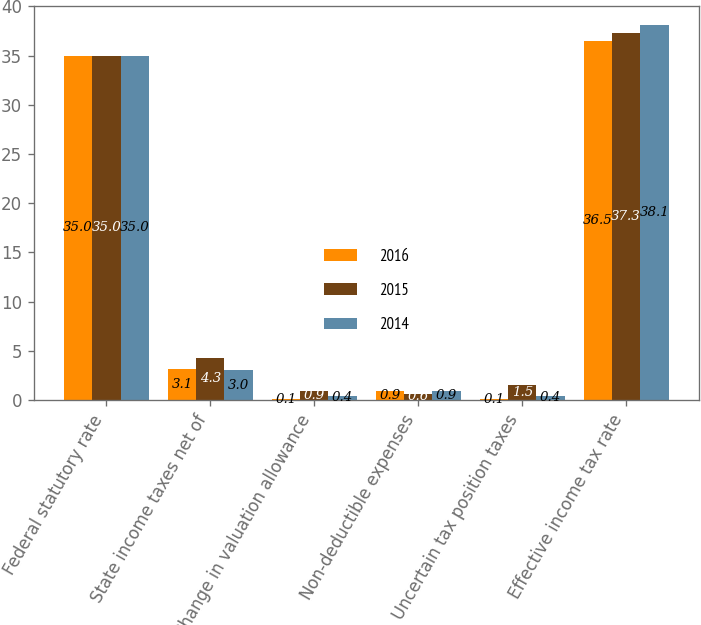Convert chart. <chart><loc_0><loc_0><loc_500><loc_500><stacked_bar_chart><ecel><fcel>Federal statutory rate<fcel>State income taxes net of<fcel>Change in valuation allowance<fcel>Non-deductible expenses<fcel>Uncertain tax position taxes<fcel>Effective income tax rate<nl><fcel>2016<fcel>35<fcel>3.1<fcel>0.1<fcel>0.9<fcel>0.1<fcel>36.5<nl><fcel>2015<fcel>35<fcel>4.3<fcel>0.9<fcel>0.6<fcel>1.5<fcel>37.3<nl><fcel>2014<fcel>35<fcel>3<fcel>0.4<fcel>0.9<fcel>0.4<fcel>38.1<nl></chart> 